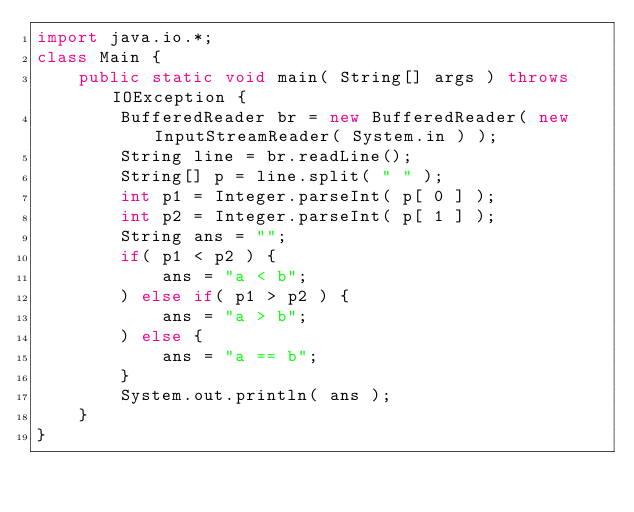<code> <loc_0><loc_0><loc_500><loc_500><_Java_>import java.io.*;
class Main {
    public static void main( String[] args ) throws IOException {
        BufferedReader br = new BufferedReader( new InputStreamReader( System.in ) );
        String line = br.readLine();
        String[] p = line.split( " " );
        int p1 = Integer.parseInt( p[ 0 ] );
        int p2 = Integer.parseInt( p[ 1 ] );
        String ans = "";
        if( p1 < p2 ) {
            ans = "a < b";
        ) else if( p1 > p2 ) {
            ans = "a > b";
        ) else {
            ans = "a == b";
        }
        System.out.println( ans );
    }
}

        </code> 